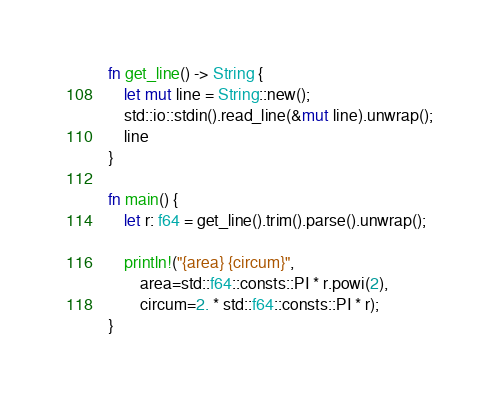Convert code to text. <code><loc_0><loc_0><loc_500><loc_500><_Rust_>fn get_line() -> String {
    let mut line = String::new();
    std::io::stdin().read_line(&mut line).unwrap();
    line
}

fn main() {
    let r: f64 = get_line().trim().parse().unwrap();

    println!("{area} {circum}",
        area=std::f64::consts::PI * r.powi(2),
        circum=2. * std::f64::consts::PI * r);
}

</code> 